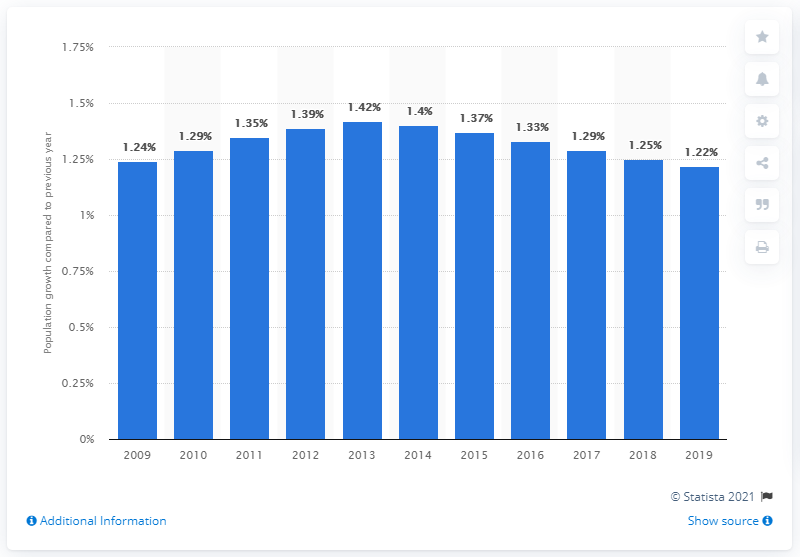Mention a couple of crucial points in this snapshot. The population of Morocco increased by 1.22% in 2019. 